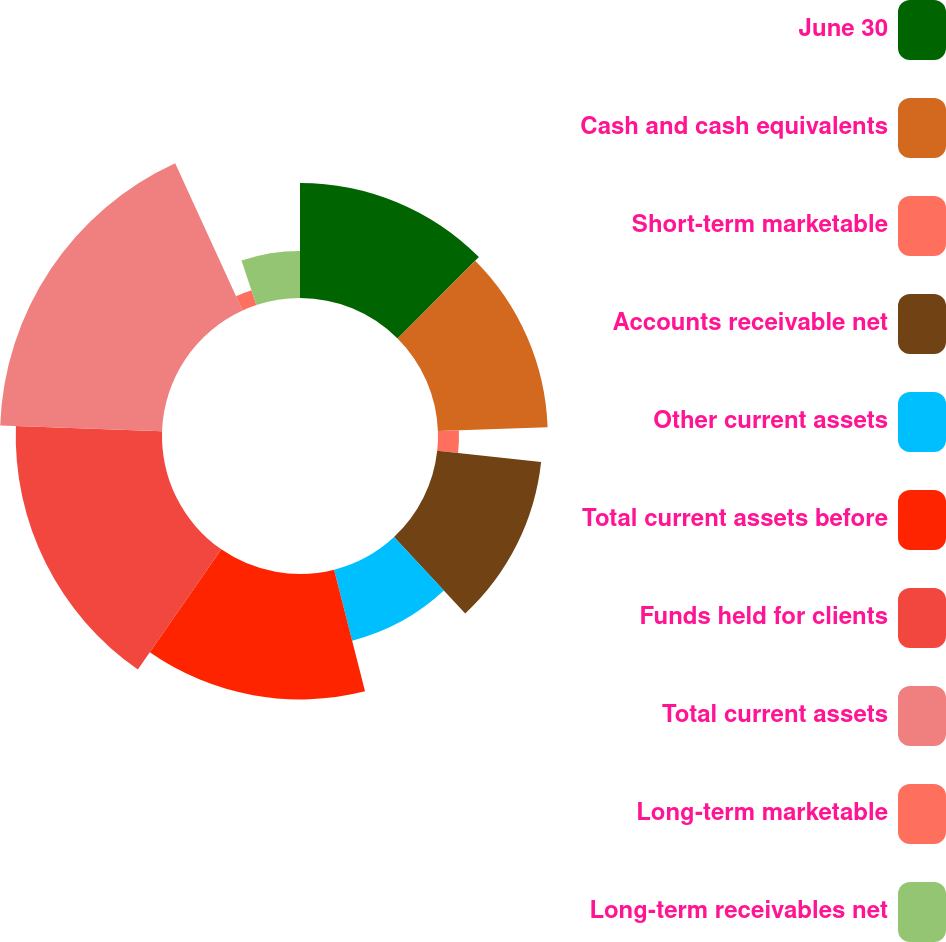Convert chart to OTSL. <chart><loc_0><loc_0><loc_500><loc_500><pie_chart><fcel>June 30<fcel>Cash and cash equivalents<fcel>Short-term marketable<fcel>Accounts receivable net<fcel>Other current assets<fcel>Total current assets before<fcel>Funds held for clients<fcel>Total current assets<fcel>Long-term marketable<fcel>Long-term receivables net<nl><fcel>12.5%<fcel>11.93%<fcel>2.28%<fcel>11.36%<fcel>7.96%<fcel>13.63%<fcel>15.9%<fcel>17.61%<fcel>1.71%<fcel>5.12%<nl></chart> 